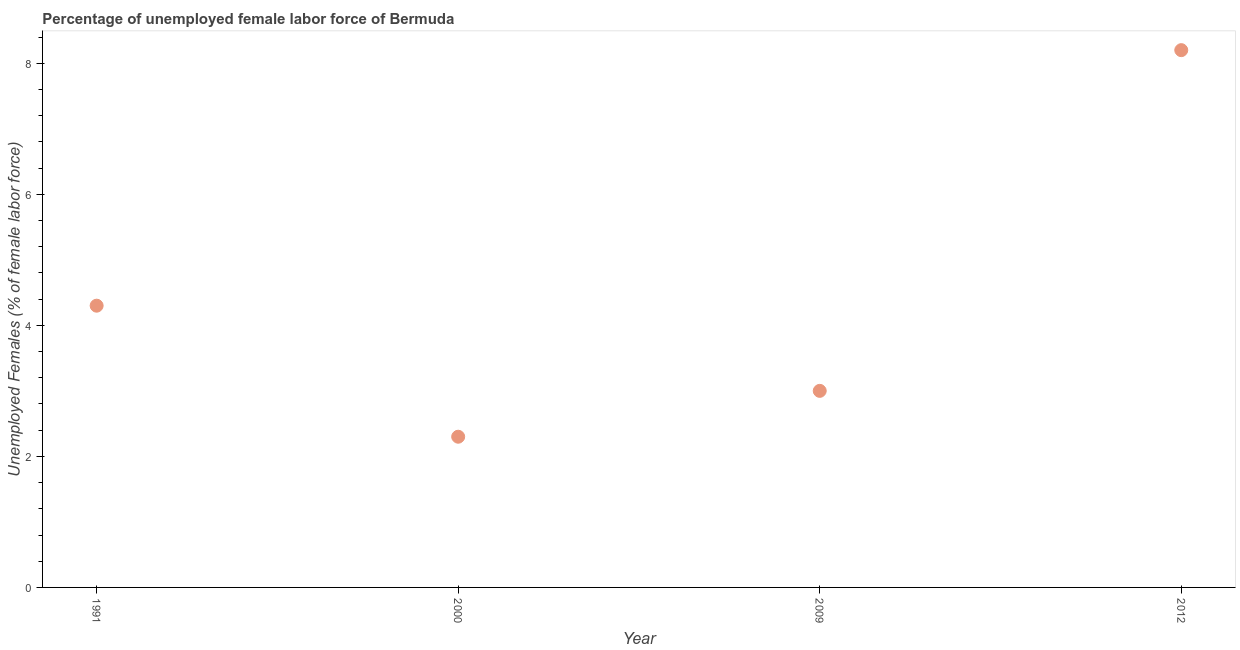What is the total unemployed female labour force in 2000?
Keep it short and to the point. 2.3. Across all years, what is the maximum total unemployed female labour force?
Offer a terse response. 8.2. Across all years, what is the minimum total unemployed female labour force?
Make the answer very short. 2.3. What is the sum of the total unemployed female labour force?
Keep it short and to the point. 17.8. What is the difference between the total unemployed female labour force in 1991 and 2012?
Keep it short and to the point. -3.9. What is the average total unemployed female labour force per year?
Offer a terse response. 4.45. What is the median total unemployed female labour force?
Provide a succinct answer. 3.65. In how many years, is the total unemployed female labour force greater than 8 %?
Provide a short and direct response. 1. What is the ratio of the total unemployed female labour force in 1991 to that in 2000?
Offer a very short reply. 1.87. Is the difference between the total unemployed female labour force in 1991 and 2012 greater than the difference between any two years?
Make the answer very short. No. What is the difference between the highest and the second highest total unemployed female labour force?
Ensure brevity in your answer.  3.9. Is the sum of the total unemployed female labour force in 2009 and 2012 greater than the maximum total unemployed female labour force across all years?
Provide a succinct answer. Yes. What is the difference between the highest and the lowest total unemployed female labour force?
Make the answer very short. 5.9. How many years are there in the graph?
Offer a terse response. 4. What is the difference between two consecutive major ticks on the Y-axis?
Ensure brevity in your answer.  2. Does the graph contain grids?
Your response must be concise. No. What is the title of the graph?
Offer a terse response. Percentage of unemployed female labor force of Bermuda. What is the label or title of the X-axis?
Offer a terse response. Year. What is the label or title of the Y-axis?
Make the answer very short. Unemployed Females (% of female labor force). What is the Unemployed Females (% of female labor force) in 1991?
Ensure brevity in your answer.  4.3. What is the Unemployed Females (% of female labor force) in 2000?
Make the answer very short. 2.3. What is the Unemployed Females (% of female labor force) in 2012?
Provide a short and direct response. 8.2. What is the difference between the Unemployed Females (% of female labor force) in 1991 and 2000?
Offer a terse response. 2. What is the difference between the Unemployed Females (% of female labor force) in 2000 and 2012?
Ensure brevity in your answer.  -5.9. What is the difference between the Unemployed Females (% of female labor force) in 2009 and 2012?
Keep it short and to the point. -5.2. What is the ratio of the Unemployed Females (% of female labor force) in 1991 to that in 2000?
Your response must be concise. 1.87. What is the ratio of the Unemployed Females (% of female labor force) in 1991 to that in 2009?
Make the answer very short. 1.43. What is the ratio of the Unemployed Females (% of female labor force) in 1991 to that in 2012?
Make the answer very short. 0.52. What is the ratio of the Unemployed Females (% of female labor force) in 2000 to that in 2009?
Provide a succinct answer. 0.77. What is the ratio of the Unemployed Females (% of female labor force) in 2000 to that in 2012?
Make the answer very short. 0.28. What is the ratio of the Unemployed Females (% of female labor force) in 2009 to that in 2012?
Offer a terse response. 0.37. 